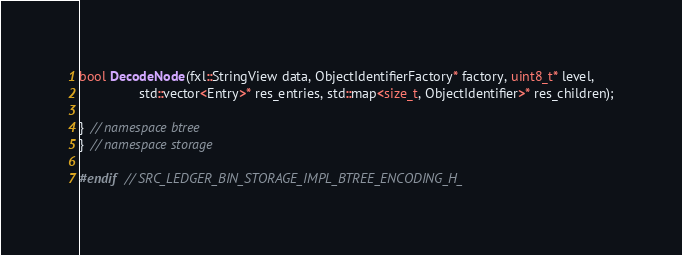<code> <loc_0><loc_0><loc_500><loc_500><_C_>
bool DecodeNode(fxl::StringView data, ObjectIdentifierFactory* factory, uint8_t* level,
                std::vector<Entry>* res_entries, std::map<size_t, ObjectIdentifier>* res_children);

}  // namespace btree
}  // namespace storage

#endif  // SRC_LEDGER_BIN_STORAGE_IMPL_BTREE_ENCODING_H_
</code> 